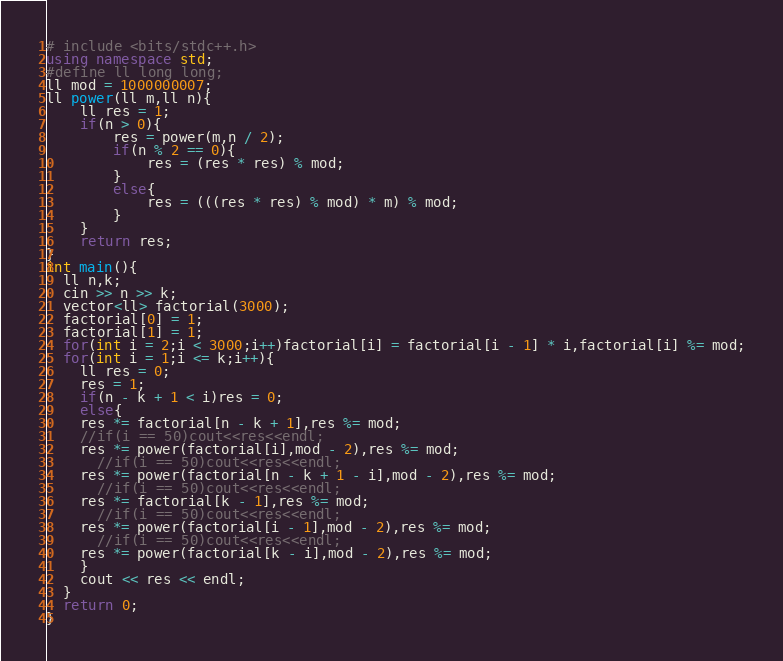Convert code to text. <code><loc_0><loc_0><loc_500><loc_500><_C++_># include <bits/stdc++.h>
using namespace std;
#define ll long long;
ll mod = 1000000007;
ll power(ll m,ll n){
    ll res = 1;
    if(n > 0){
        res = power(m,n / 2);
        if(n % 2 == 0){
            res = (res * res) % mod;
        }
        else{
            res = (((res * res) % mod) * m) % mod;
        }
    }
    return res;
}
int main(){
  ll n,k;
  cin >> n >> k;
  vector<ll> factorial(3000);
  factorial[0] = 1;
  factorial[1] = 1;
  for(int i = 2;i < 3000;i++)factorial[i] = factorial[i - 1] * i,factorial[i] %= mod;
  for(int i = 1;i <= k;i++){
    ll res = 0;
    res = 1;
    if(n - k + 1 < i)res = 0;
    else{
    res *= factorial[n - k + 1],res %= mod;
    //if(i == 50)cout<<res<<endl;
    res *= power(factorial[i],mod - 2),res %= mod;
      //if(i == 50)cout<<res<<endl;
    res *= power(factorial[n - k + 1 - i],mod - 2),res %= mod;
      //if(i == 50)cout<<res<<endl;
    res *= factorial[k - 1],res %= mod;
      //if(i == 50)cout<<res<<endl;
    res *= power(factorial[i - 1],mod - 2),res %= mod;
      //if(i == 50)cout<<res<<endl;
    res *= power(factorial[k - i],mod - 2),res %= mod;
    }
    cout << res << endl;
  }
  return 0;
}
</code> 